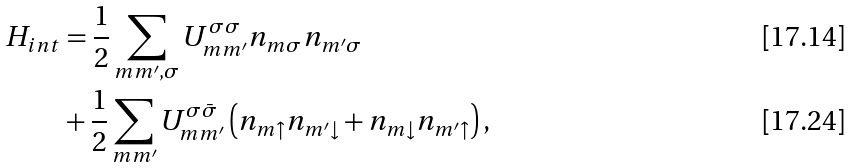<formula> <loc_0><loc_0><loc_500><loc_500>H _ { i n t } & = \frac { 1 } { 2 } \sum _ { m m ^ { \prime } , \sigma } U _ { m m ^ { \prime } } ^ { \sigma \sigma } n _ { m \sigma } n _ { m ^ { \prime } \sigma } \\ & + \frac { 1 } { 2 } \sum _ { m m ^ { \prime } } U _ { m m ^ { \prime } } ^ { \sigma \bar { \sigma } } \left ( n _ { m \uparrow } n _ { m ^ { \prime } \downarrow } + n _ { m \downarrow } n _ { m ^ { \prime } \uparrow } \right ) ,</formula> 